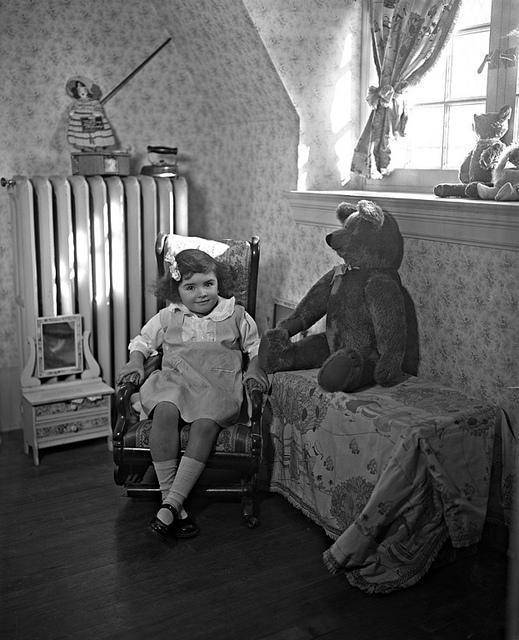How many kids are sitting down?
Give a very brief answer. 1. How many teddy bears are there?
Give a very brief answer. 2. How many horses in the fence?
Give a very brief answer. 0. 